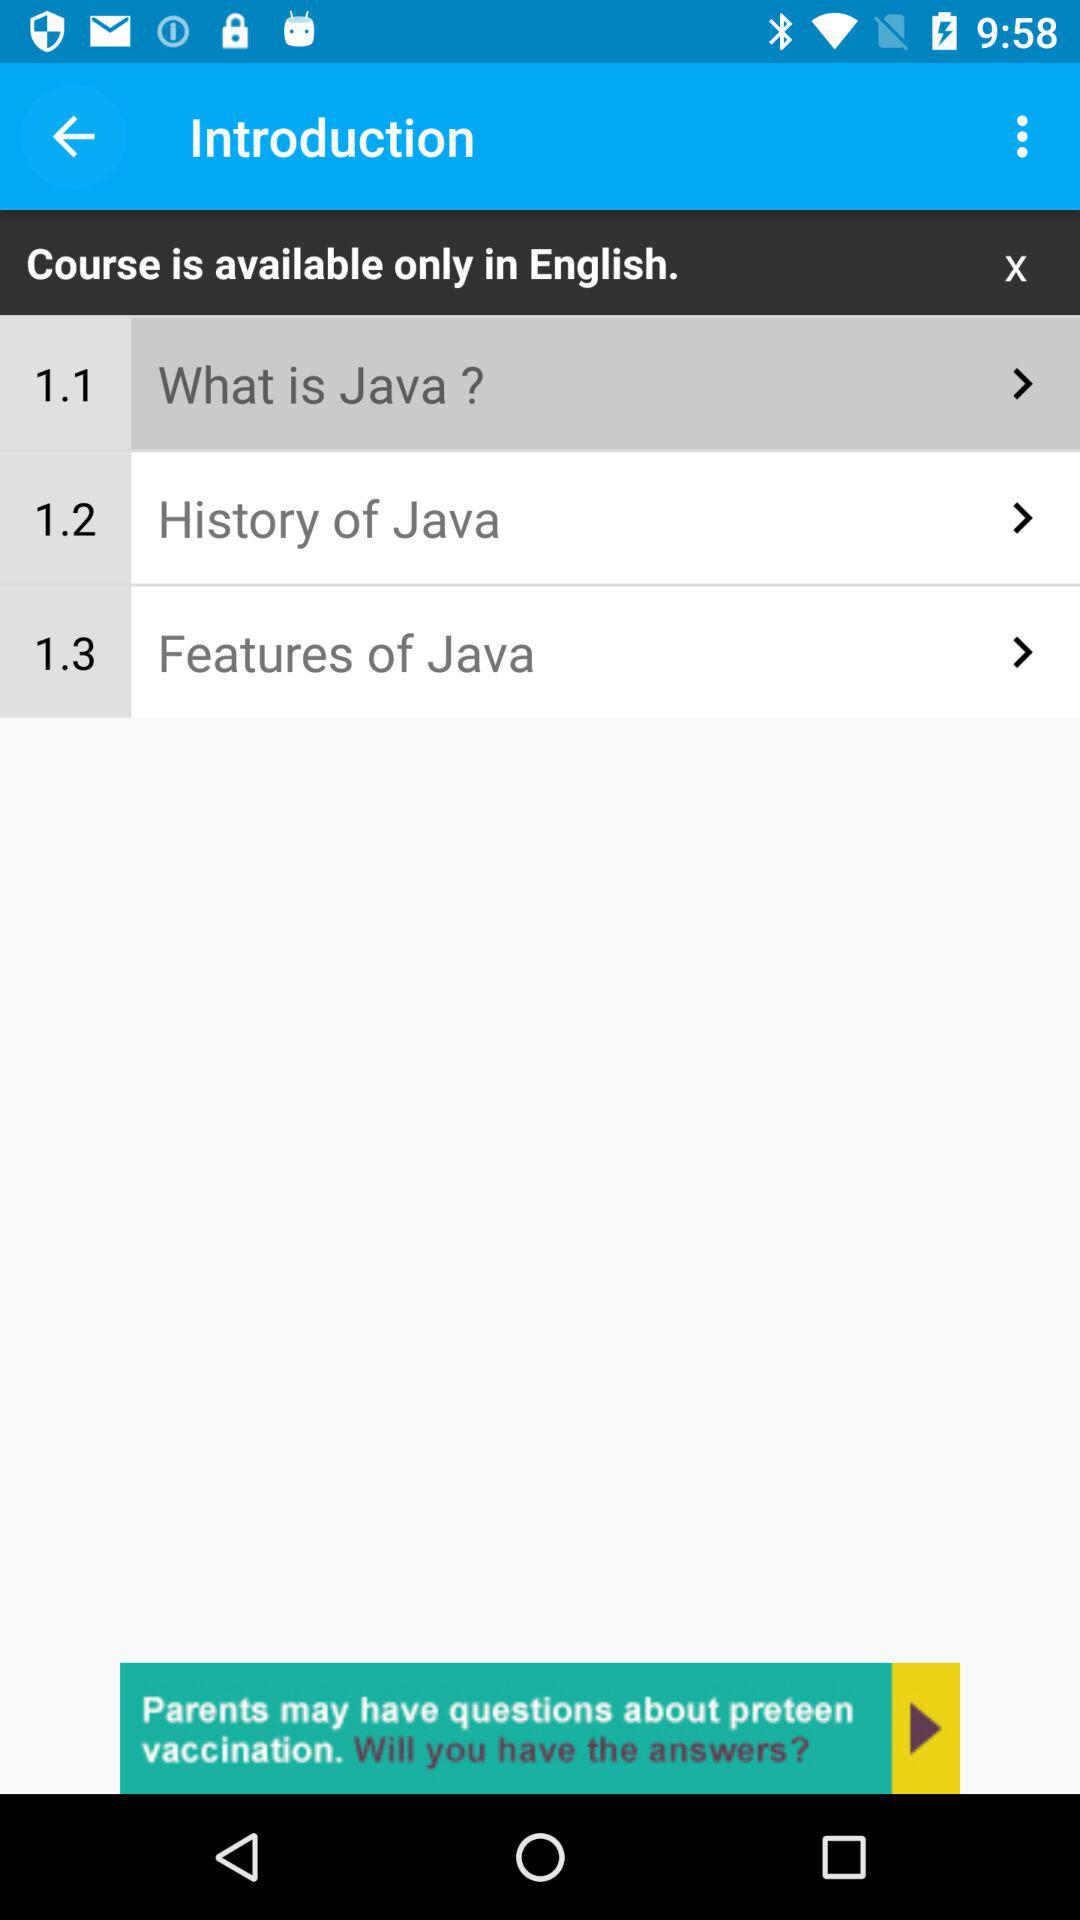What is the name of the topic 1.3? The name of the topic is "Features of Java". 